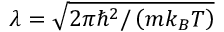<formula> <loc_0><loc_0><loc_500><loc_500>\lambda = \sqrt { 2 \pi \hbar { ^ } { 2 } / \left ( m k _ { B } T \right ) }</formula> 